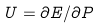<formula> <loc_0><loc_0><loc_500><loc_500>U = \partial E / \partial P</formula> 